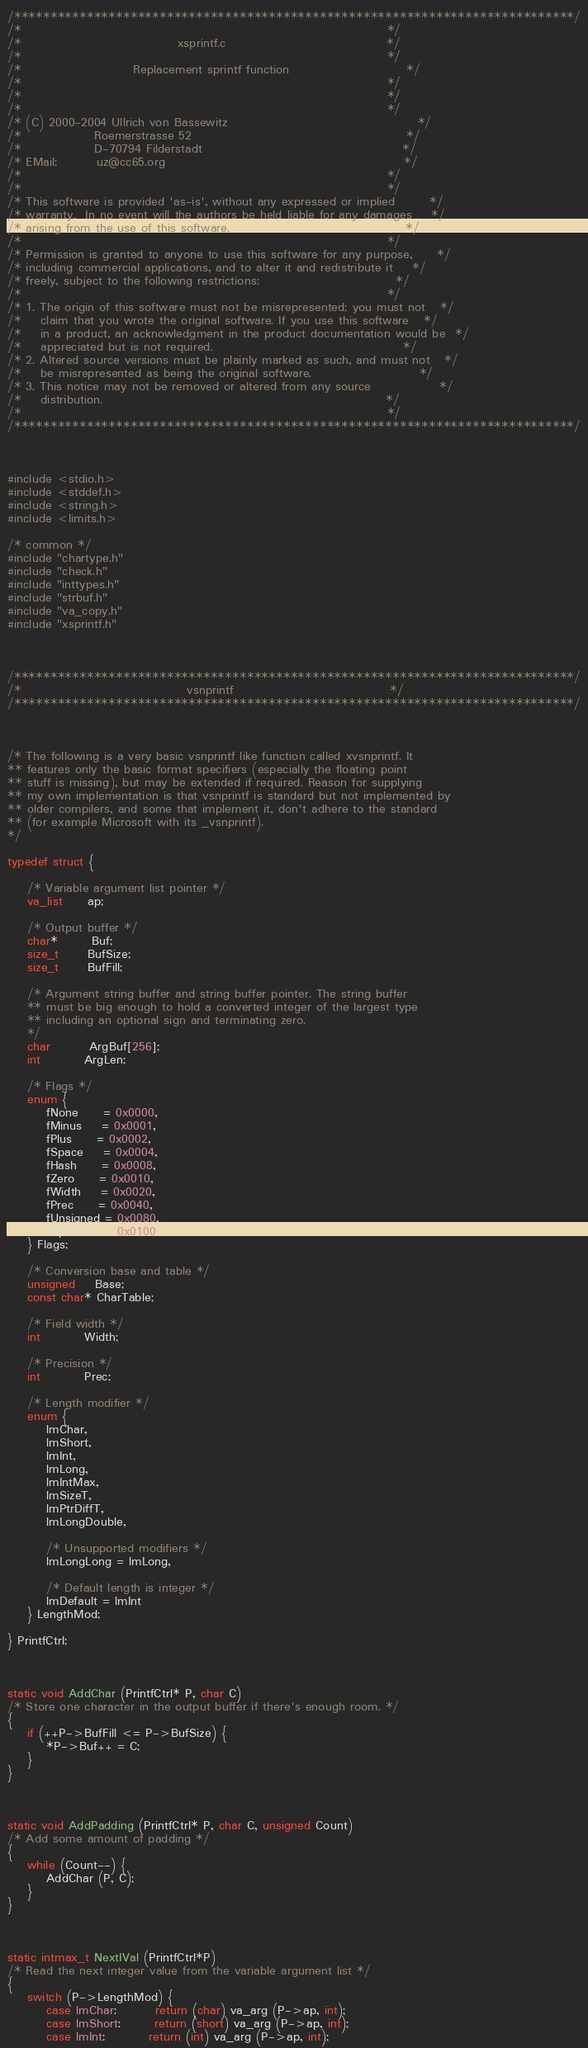Convert code to text. <code><loc_0><loc_0><loc_500><loc_500><_C_>/*****************************************************************************/
/*                                                                           */
/*                                xsprintf.c                                 */
/*                                                                           */
/*                       Replacement sprintf function                        */
/*                                                                           */
/*                                                                           */
/*                                                                           */
/* (C) 2000-2004 Ullrich von Bassewitz                                       */
/*               Roemerstrasse 52                                            */
/*               D-70794 Filderstadt                                         */
/* EMail:        uz@cc65.org                                                 */
/*                                                                           */
/*                                                                           */
/* This software is provided 'as-is', without any expressed or implied       */
/* warranty.  In no event will the authors be held liable for any damages    */
/* arising from the use of this software.                                    */
/*                                                                           */
/* Permission is granted to anyone to use this software for any purpose,     */
/* including commercial applications, and to alter it and redistribute it    */
/* freely, subject to the following restrictions:                            */
/*                                                                           */
/* 1. The origin of this software must not be misrepresented; you must not   */
/*    claim that you wrote the original software. If you use this software   */
/*    in a product, an acknowledgment in the product documentation would be  */
/*    appreciated but is not required.                                       */
/* 2. Altered source versions must be plainly marked as such, and must not   */
/*    be misrepresented as being the original software.                      */
/* 3. This notice may not be removed or altered from any source              */
/*    distribution.                                                          */
/*                                                                           */
/*****************************************************************************/



#include <stdio.h>
#include <stddef.h>
#include <string.h>
#include <limits.h>

/* common */
#include "chartype.h"
#include "check.h"
#include "inttypes.h"
#include "strbuf.h"
#include "va_copy.h"
#include "xsprintf.h"



/*****************************************************************************/
/*                                  vsnprintf                                */
/*****************************************************************************/



/* The following is a very basic vsnprintf like function called xvsnprintf. It
** features only the basic format specifiers (especially the floating point
** stuff is missing), but may be extended if required. Reason for supplying
** my own implementation is that vsnprintf is standard but not implemented by
** older compilers, and some that implement it, don't adhere to the standard
** (for example Microsoft with its _vsnprintf).
*/

typedef struct {

    /* Variable argument list pointer */
    va_list     ap;

    /* Output buffer */
    char*       Buf;
    size_t      BufSize;
    size_t      BufFill;

    /* Argument string buffer and string buffer pointer. The string buffer
    ** must be big enough to hold a converted integer of the largest type
    ** including an optional sign and terminating zero.
    */
    char        ArgBuf[256];
    int         ArgLen;

    /* Flags */
    enum {
        fNone     = 0x0000,
        fMinus    = 0x0001,
        fPlus     = 0x0002,
        fSpace    = 0x0004,
        fHash     = 0x0008,
        fZero     = 0x0010,
        fWidth    = 0x0020,
        fPrec     = 0x0040,
        fUnsigned = 0x0080,
        fUpcase   = 0x0100
    } Flags;

    /* Conversion base and table */
    unsigned    Base;
    const char* CharTable;

    /* Field width */
    int         Width;

    /* Precision */
    int         Prec;

    /* Length modifier */
    enum {
        lmChar,
        lmShort,
        lmInt,
        lmLong,
        lmIntMax,
        lmSizeT,
        lmPtrDiffT,
        lmLongDouble,

        /* Unsupported modifiers */
        lmLongLong = lmLong,

        /* Default length is integer */
        lmDefault = lmInt
    } LengthMod;

} PrintfCtrl;



static void AddChar (PrintfCtrl* P, char C)
/* Store one character in the output buffer if there's enough room. */
{
    if (++P->BufFill <= P->BufSize) {
        *P->Buf++ = C;
    }
}



static void AddPadding (PrintfCtrl* P, char C, unsigned Count)
/* Add some amount of padding */
{
    while (Count--) {
        AddChar (P, C);
    }
}



static intmax_t NextIVal (PrintfCtrl*P)
/* Read the next integer value from the variable argument list */
{
    switch (P->LengthMod) {
        case lmChar:        return (char) va_arg (P->ap, int);
        case lmShort:       return (short) va_arg (P->ap, int);
        case lmInt:         return (int) va_arg (P->ap, int);</code> 